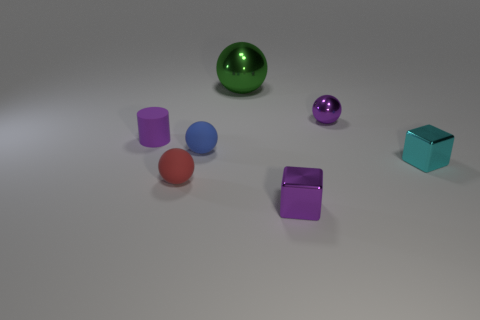Are there any other things that are the same size as the green shiny thing?
Your answer should be compact. No. Is the color of the cylinder the same as the tiny metallic sphere?
Keep it short and to the point. Yes. Are there any large green shiny balls left of the green object?
Your answer should be compact. No. How many green shiny things are in front of the metal sphere that is to the right of the big green metal sphere?
Provide a succinct answer. 0. The other sphere that is made of the same material as the purple ball is what size?
Your answer should be compact. Large. The green object has what size?
Provide a short and direct response. Large. Are the tiny purple block and the tiny red sphere made of the same material?
Your answer should be very brief. No. What number of cubes are either small purple things or blue objects?
Offer a terse response. 1. There is a small ball on the right side of the metallic sphere that is behind the small purple sphere; what color is it?
Provide a short and direct response. Purple. What size is the matte cylinder that is the same color as the tiny metal sphere?
Ensure brevity in your answer.  Small. 